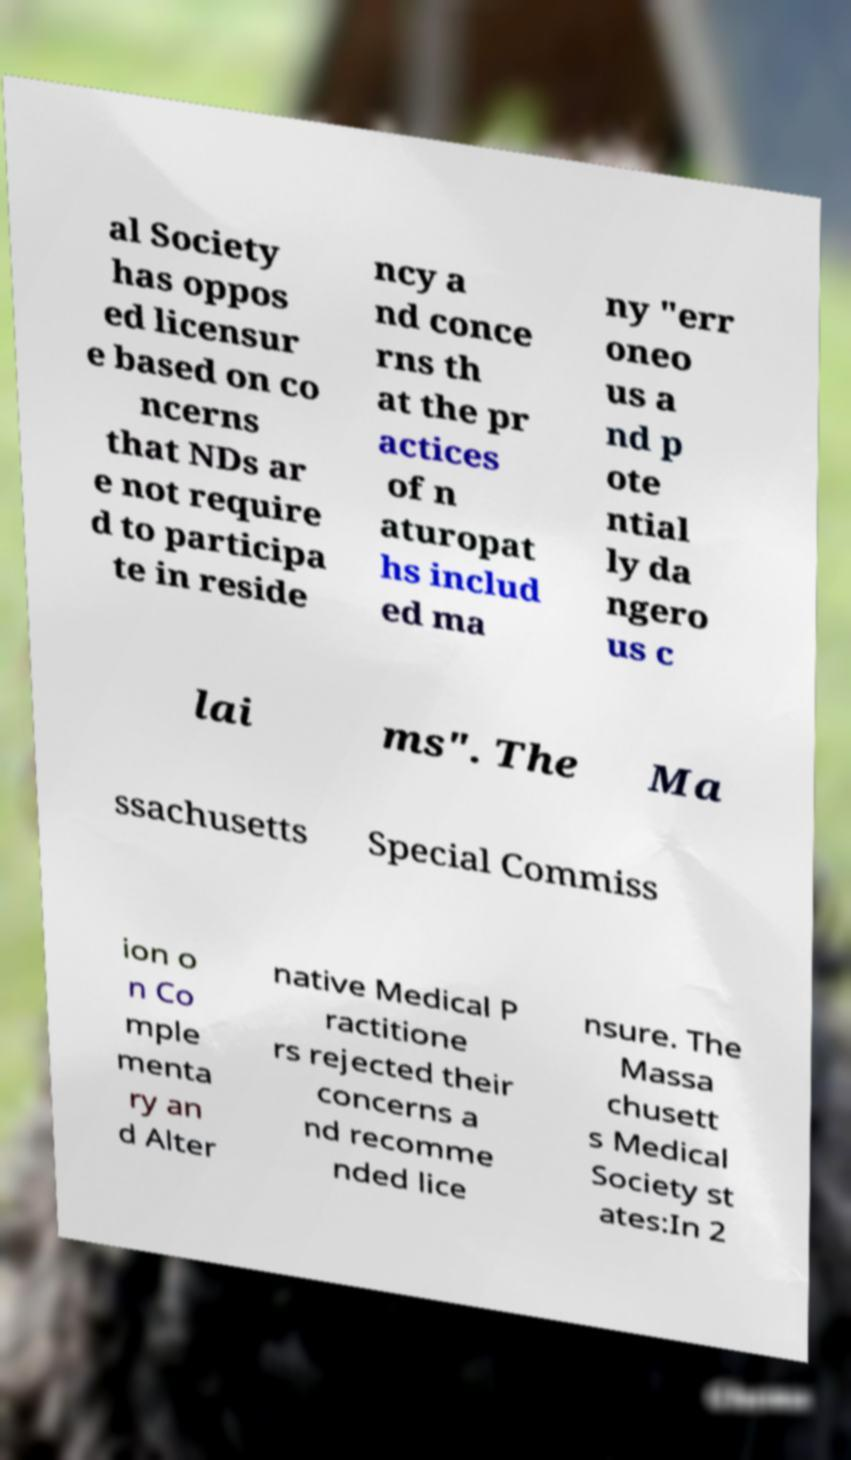What messages or text are displayed in this image? I need them in a readable, typed format. al Society has oppos ed licensur e based on co ncerns that NDs ar e not require d to participa te in reside ncy a nd conce rns th at the pr actices of n aturopat hs includ ed ma ny "err oneo us a nd p ote ntial ly da ngero us c lai ms". The Ma ssachusetts Special Commiss ion o n Co mple menta ry an d Alter native Medical P ractitione rs rejected their concerns a nd recomme nded lice nsure. The Massa chusett s Medical Society st ates:In 2 